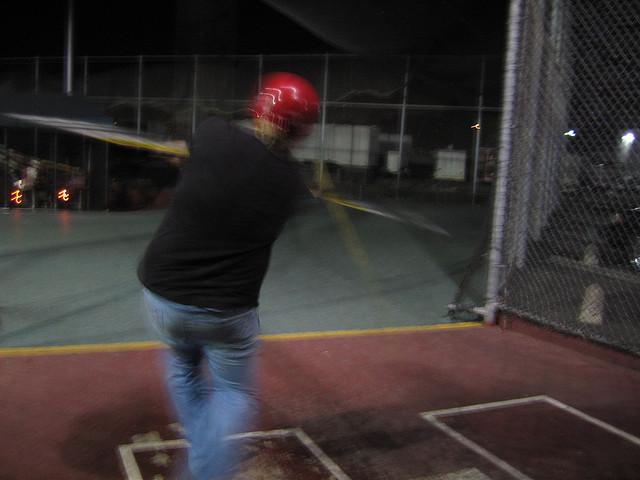Did he just swing the bat?
Be succinct. Yes. What color is the helmet?
Keep it brief. Red. Is the person wearing a uniform?
Give a very brief answer. No. 